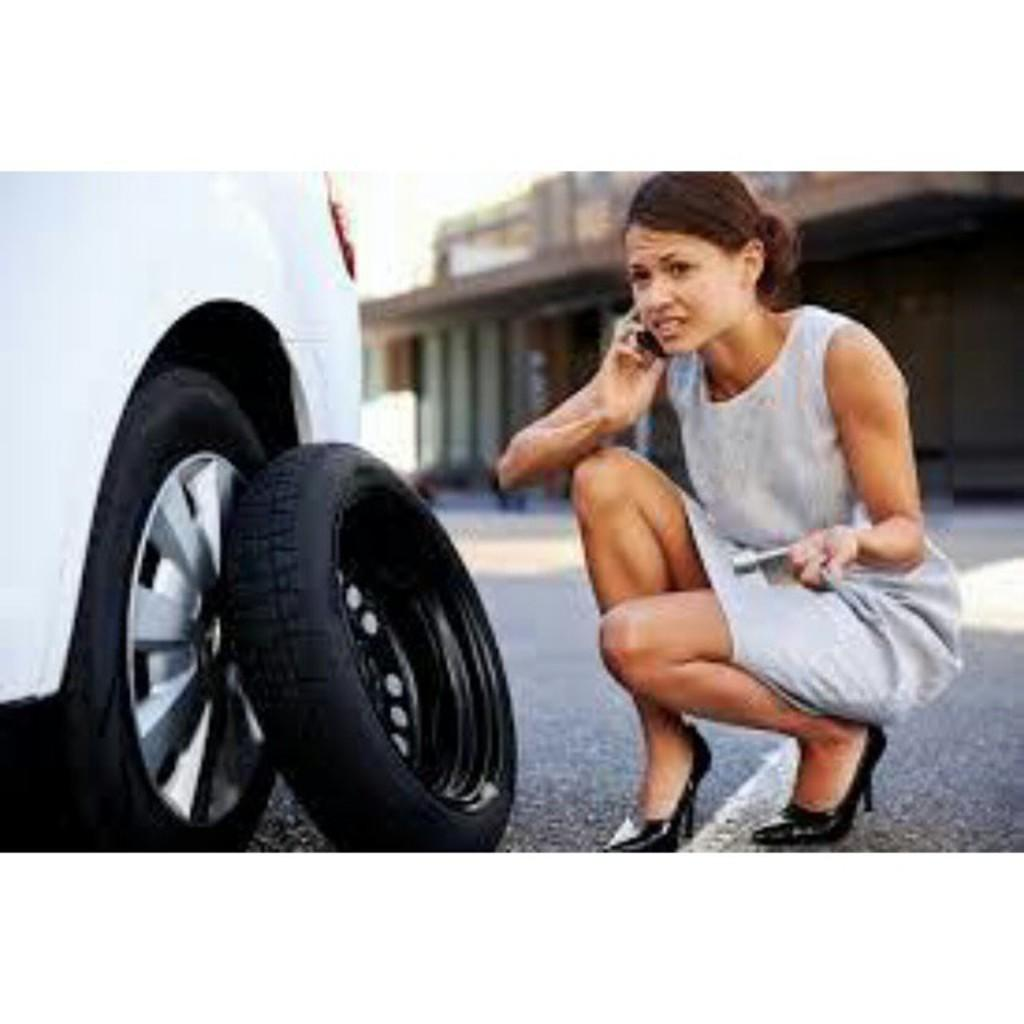Who is present in the image? There is a woman in the image. What is the woman doing in the image? The woman is holding a mobile near her ear. What can be seen in the foreground of the image? There is a vehicle wheel and a tire in front of the vehicle wheel. Can you describe the background of the image? The background of the image is blurred. How many hens are visible in the image? There are no hens present in the image. What type of square pattern can be seen on the woman's clothing in the image? There is no square pattern visible on the woman's clothing in the image. 